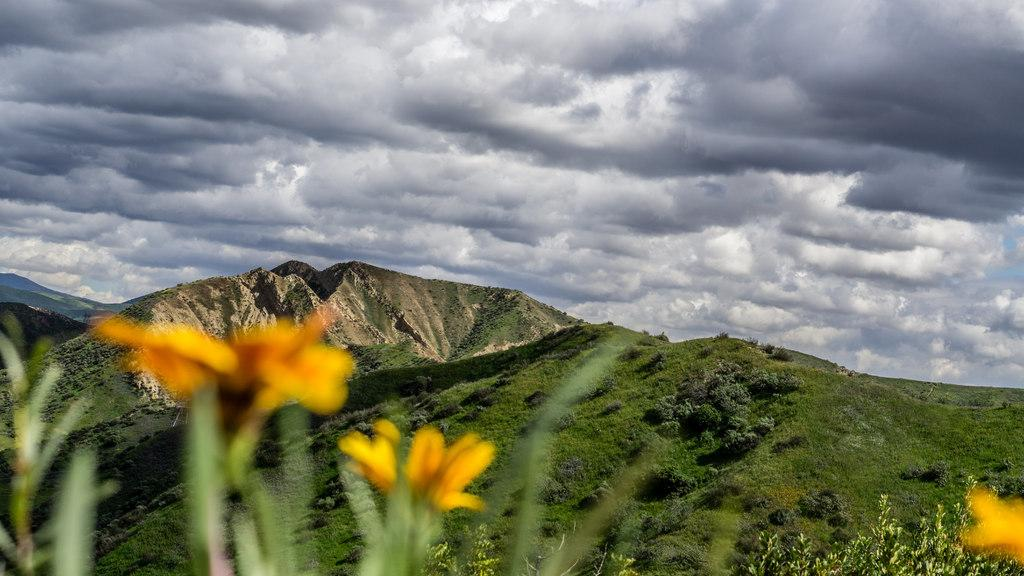What type of scene is depicted in the image? The image contains a beautiful nature scene. What can be seen in the foreground of the image? There are yellow flowers in the front of the image. What is visible in the background of the image? There is a mountain with many trees in the background of the image. What part of the sky can be seen in the image? The sky is visible in the image. What is present in the sky? Clouds are present in the sky. Where is the kitten located on the edge of the mountain in the image? There is no kitten present in the image, and the edge of the mountain is not visible. 